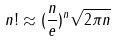Convert formula to latex. <formula><loc_0><loc_0><loc_500><loc_500>n ! \approx ( \frac { n } { e } ) ^ { n } \sqrt { 2 \pi n }</formula> 